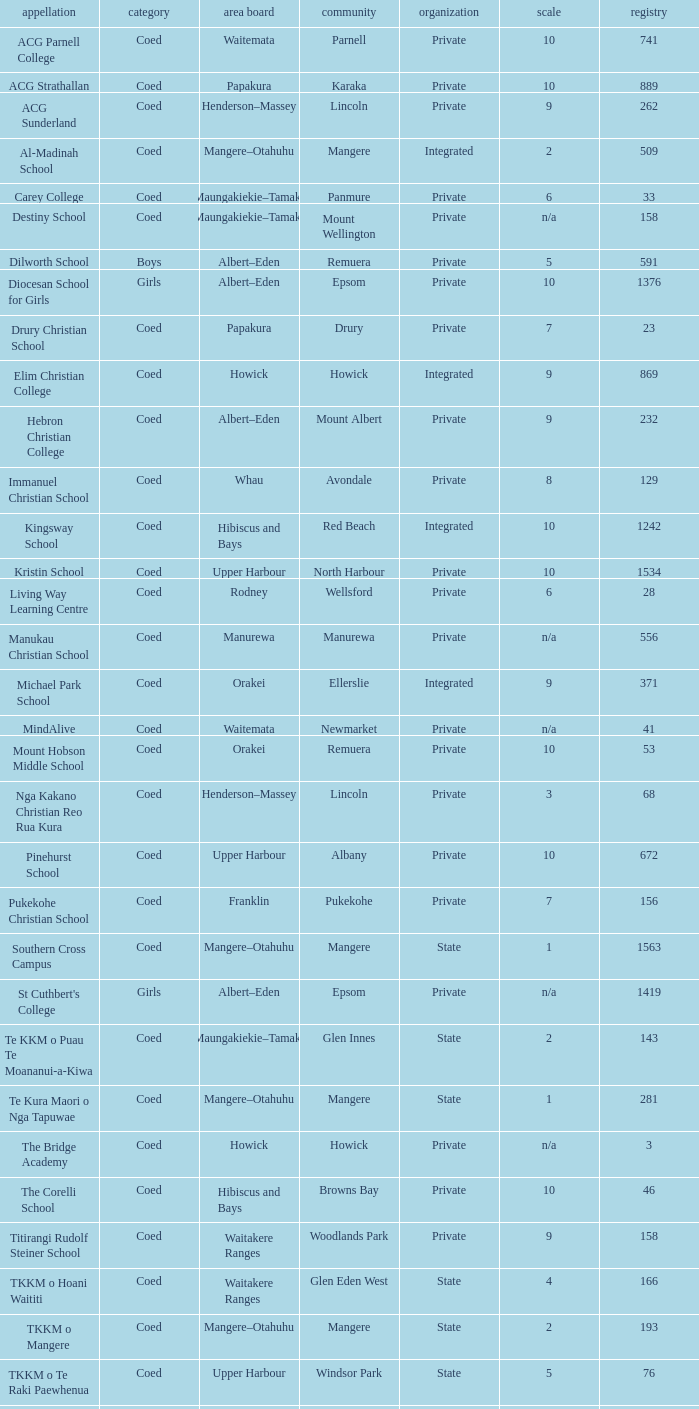What is the name when the local board is albert–eden, and a Decile of 9? Hebron Christian College. 